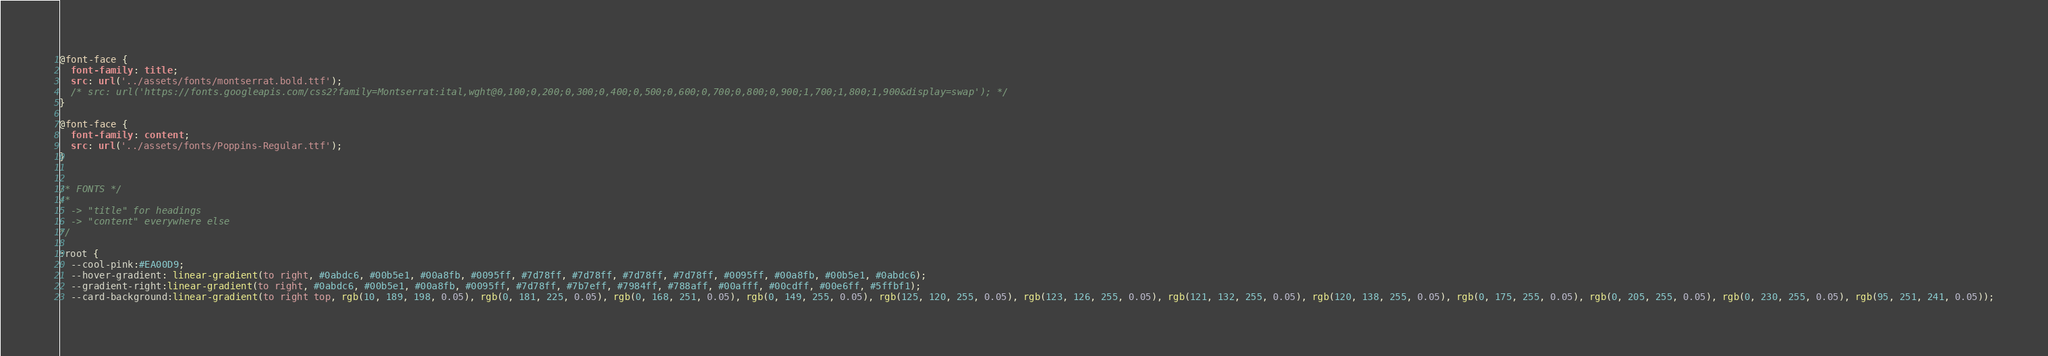Convert code to text. <code><loc_0><loc_0><loc_500><loc_500><_CSS_>@font-face {
  font-family: title;
  src: url('../assets/fonts/montserrat.bold.ttf');
  /* src: url('https://fonts.googleapis.com/css2?family=Montserrat:ital,wght@0,100;0,200;0,300;0,400;0,500;0,600;0,700;0,800;0,900;1,700;1,800;1,900&display=swap'); */
}

@font-face {
  font-family: content;
  src: url('../assets/fonts/Poppins-Regular.ttf');
}


/* FONTS */
/* 
  -> "title" for headings
  -> "content" everywhere else
*/

:root {
  --cool-pink:#EA00D9;
  --hover-gradient: linear-gradient(to right, #0abdc6, #00b5e1, #00a8fb, #0095ff, #7d78ff, #7d78ff, #7d78ff, #7d78ff, #0095ff, #00a8fb, #00b5e1, #0abdc6);
  --gradient-right:linear-gradient(to right, #0abdc6, #00b5e1, #00a8fb, #0095ff, #7d78ff, #7b7eff, #7984ff, #788aff, #00afff, #00cdff, #00e6ff, #5ffbf1);
  --card-background:linear-gradient(to right top, rgb(10, 189, 198, 0.05), rgb(0, 181, 225, 0.05), rgb(0, 168, 251, 0.05), rgb(0, 149, 255, 0.05), rgb(125, 120, 255, 0.05), rgb(123, 126, 255, 0.05), rgb(121, 132, 255, 0.05), rgb(120, 138, 255, 0.05), rgb(0, 175, 255, 0.05), rgb(0, 205, 255, 0.05), rgb(0, 230, 255, 0.05), rgb(95, 251, 241, 0.05));</code> 